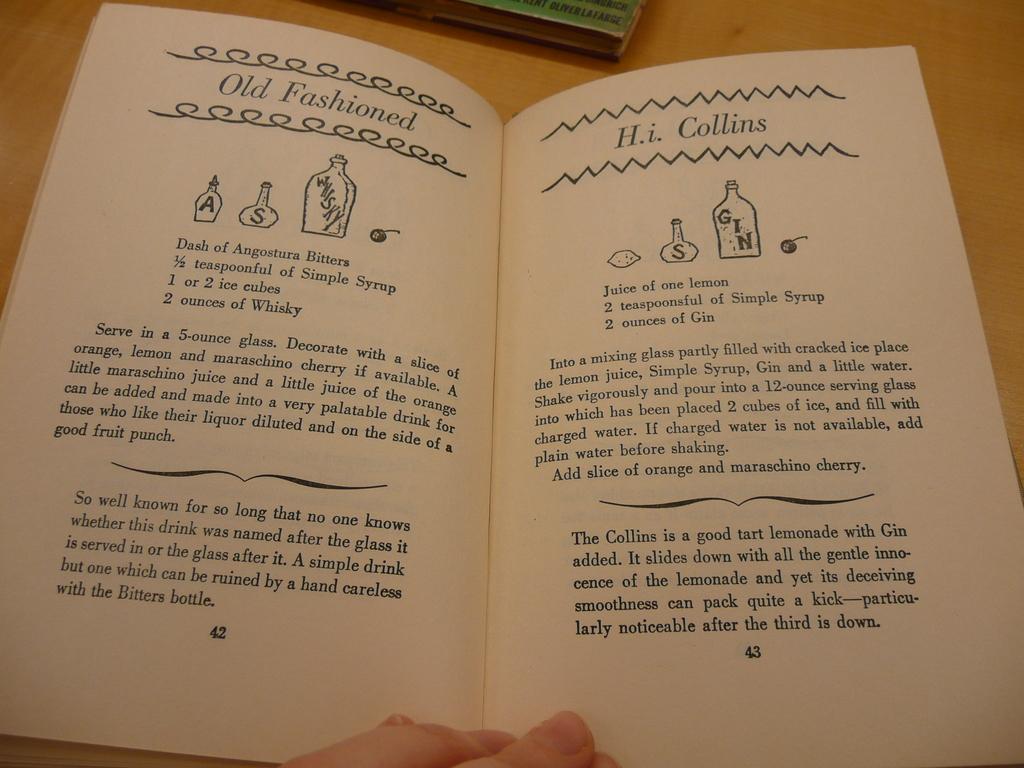What number page is on the right side of the book?
Make the answer very short. 43. 